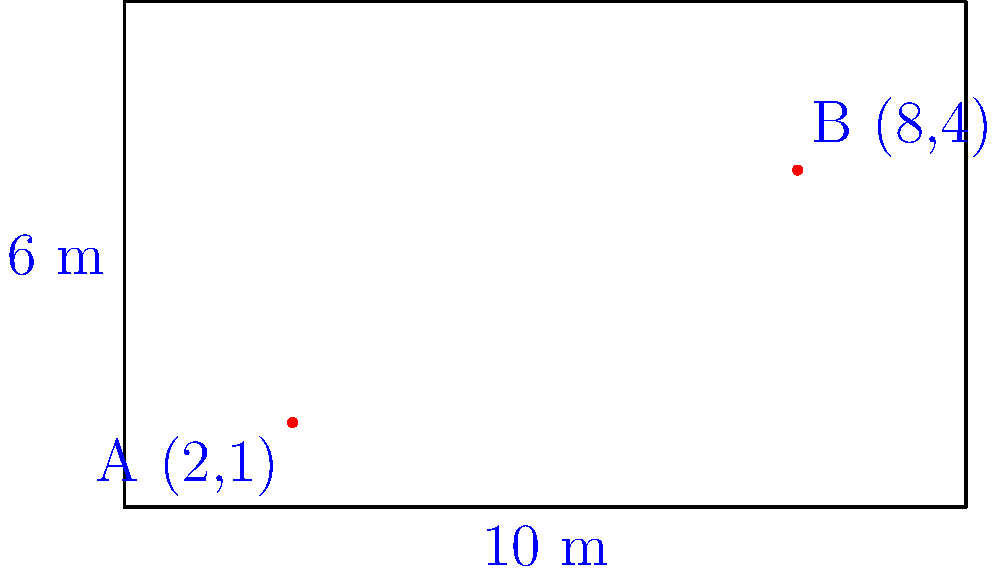In a traditional Malaysian dance performance, two dancers are positioned on a rectangular stage that measures 10 meters in length and 6 meters in width. Dancer A is located at coordinates (2,1), while Dancer B is at (8,4). What is the straight-line distance between the two dancers, rounded to the nearest centimeter? To find the straight-line distance between the two dancers, we can use the distance formula derived from the Pythagorean theorem. Here's how to solve this step-by-step:

1. Identify the coordinates:
   Dancer A: $(x_1, y_1) = (2, 1)$
   Dancer B: $(x_2, y_2) = (8, 4)$

2. Use the distance formula:
   $d = \sqrt{(x_2 - x_1)^2 + (y_2 - y_1)^2}$

3. Substitute the values:
   $d = \sqrt{(8 - 2)^2 + (4 - 1)^2}$

4. Simplify inside the parentheses:
   $d = \sqrt{6^2 + 3^2}$

5. Calculate the squares:
   $d = \sqrt{36 + 9}$

6. Add under the square root:
   $d = \sqrt{45}$

7. Simplify the square root:
   $d = 3\sqrt{5}$

8. Calculate the approximate value:
   $d \approx 6.7082$ meters

9. Round to the nearest centimeter:
   $d \approx 6.71$ meters

Therefore, the straight-line distance between the two dancers is approximately 6.71 meters.
Answer: 6.71 m 